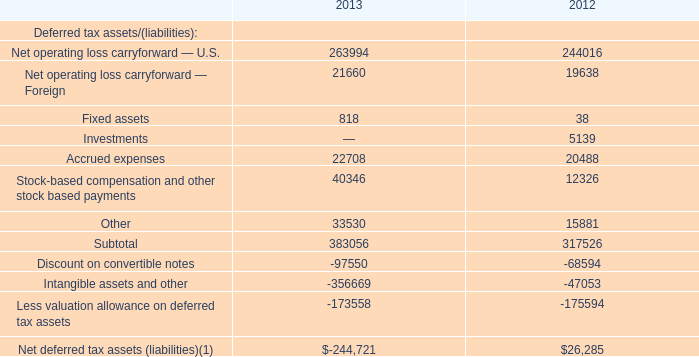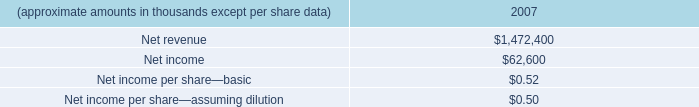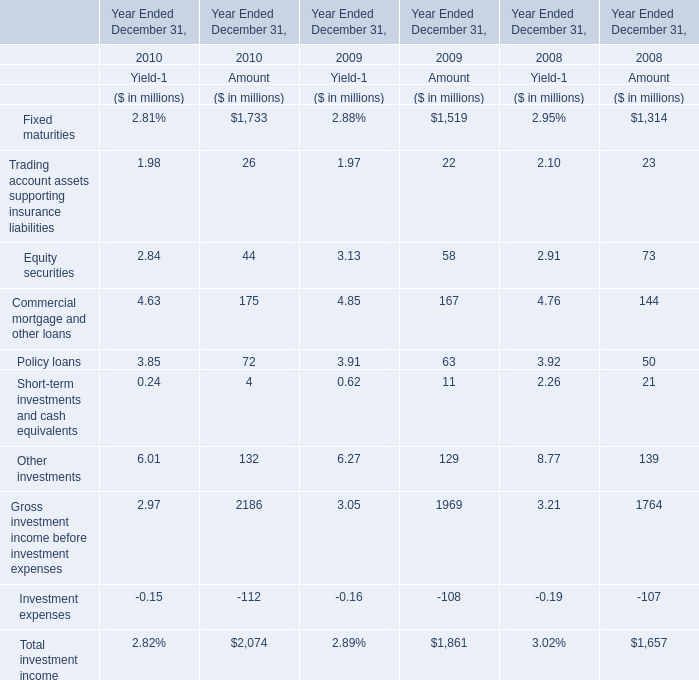In the year Ended December 31 the Amount of Equity securities is the highest, what's the Amount of Short-term investments and cash equivalents? (in million) 
Answer: 21. 